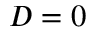Convert formula to latex. <formula><loc_0><loc_0><loc_500><loc_500>D = 0</formula> 